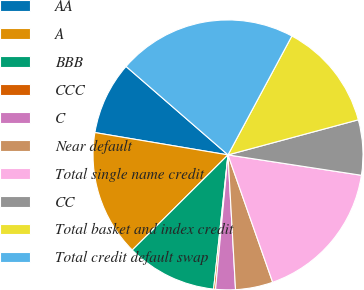<chart> <loc_0><loc_0><loc_500><loc_500><pie_chart><fcel>AA<fcel>A<fcel>BBB<fcel>CCC<fcel>C<fcel>Near default<fcel>Total single name credit<fcel>CC<fcel>Total basket and index credit<fcel>Total credit default swap<nl><fcel>8.73%<fcel>15.1%<fcel>10.85%<fcel>0.23%<fcel>2.36%<fcel>4.48%<fcel>17.22%<fcel>6.6%<fcel>12.97%<fcel>21.47%<nl></chart> 